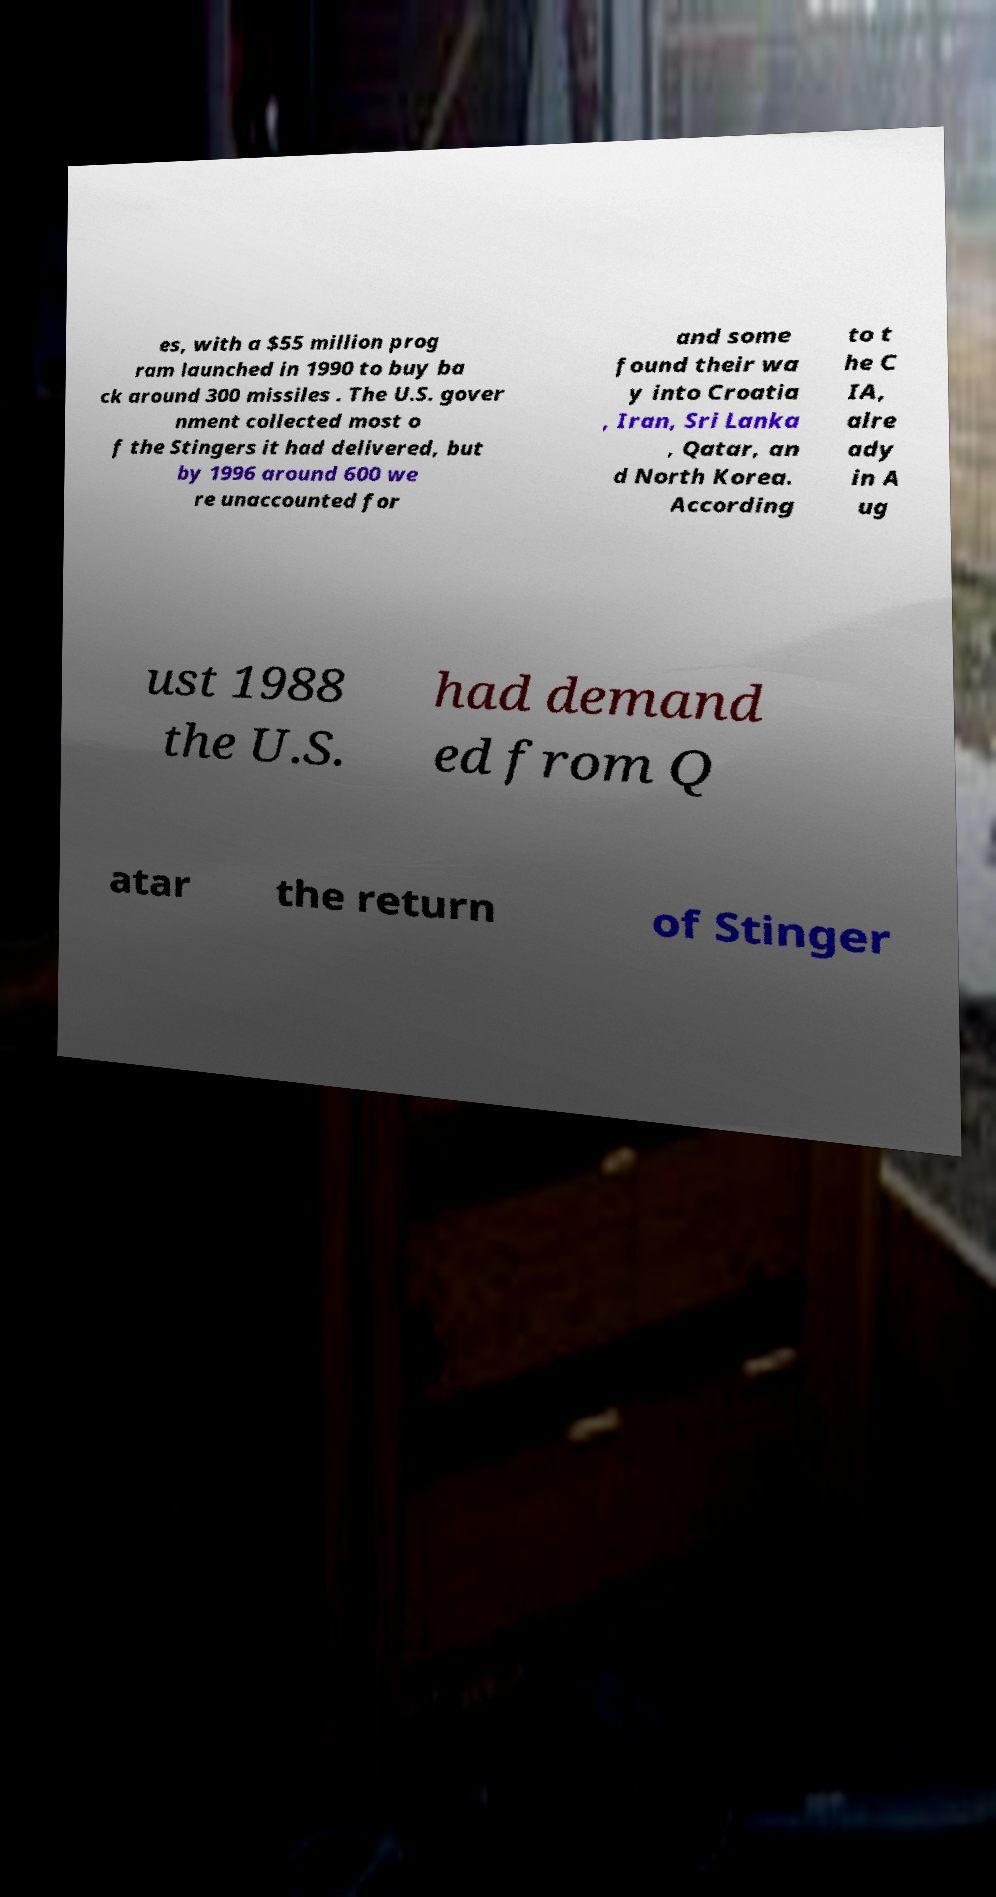Could you assist in decoding the text presented in this image and type it out clearly? es, with a $55 million prog ram launched in 1990 to buy ba ck around 300 missiles . The U.S. gover nment collected most o f the Stingers it had delivered, but by 1996 around 600 we re unaccounted for and some found their wa y into Croatia , Iran, Sri Lanka , Qatar, an d North Korea. According to t he C IA, alre ady in A ug ust 1988 the U.S. had demand ed from Q atar the return of Stinger 